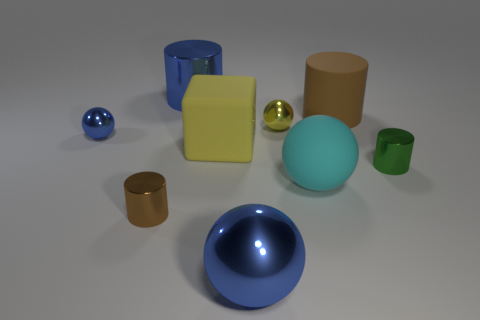Subtract all brown matte cylinders. How many cylinders are left? 3 Add 1 small blue metallic things. How many objects exist? 10 Subtract all blue cylinders. How many cylinders are left? 3 Subtract 2 cylinders. How many cylinders are left? 2 Subtract all balls. How many objects are left? 5 Subtract all purple cubes. How many gray balls are left? 0 Subtract all blue metallic things. Subtract all large yellow matte cubes. How many objects are left? 5 Add 7 brown metal objects. How many brown metal objects are left? 8 Add 9 large purple blocks. How many large purple blocks exist? 9 Subtract 0 brown cubes. How many objects are left? 9 